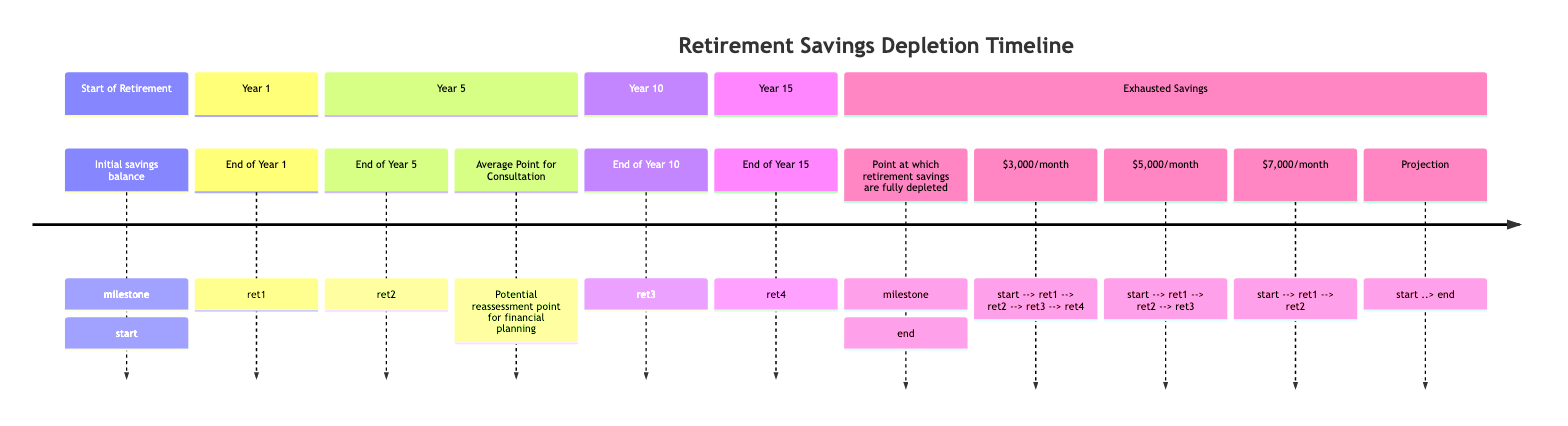What is the initial savings balance? The diagram does not specify a numeric value for the initial savings balance, but it is the starting point before any depletion occurs.
Answer: Initial savings balance At what year is the average point for consultation? The average point for consultation is marked at Year 5, indicating a potential reassessment point for financial planning.
Answer: Year 5 What is the monthly elder care cost that depletes savings by Year 10? At a monthly elder care cost of $5,000, savings are depleted by Year 10 based on the timeline provided in the diagram.
Answer: $5,000/month How many total milestones are shown in the timeline? The timeline has three milestones: End of Year 1, End of Year 5, and End of Year 10, plus the initial and exhausted savings milestones, totaling five.
Answer: Five Which monthly elder care cost results in depletion after Year 15? The monthly elder care cost of $3,000 allows for savings to be depleted by Year 15 according to the timeline flow.
Answer: $3,000/month What happens at the end of Year 5 with a $7,000/month cost? With a $7,000/month cost, depletion occurs before reaching Year 5, indicating that savings are exhausted earlier than Year 10.
Answer: Exhausted savings If savings are at the end of Year 1, which elder care costs still allow savings at Year 10? $3,000/month and $5,000/month allow savings to continue until Year 10; $7,000/month does not.
Answer: $3,000/month, $5,000/month What is the end milestone indicating? The end milestone indicates the point at which retirement savings are fully depleted after covering elder care costs.
Answer: Fully depleted savings 